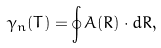Convert formula to latex. <formula><loc_0><loc_0><loc_500><loc_500>\gamma _ { n } ( T ) = \oint { A } ( { R } ) \cdot d { R } ,</formula> 